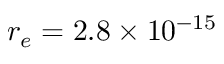Convert formula to latex. <formula><loc_0><loc_0><loc_500><loc_500>r _ { e } = 2 . 8 \times 1 0 ^ { - 1 5 }</formula> 